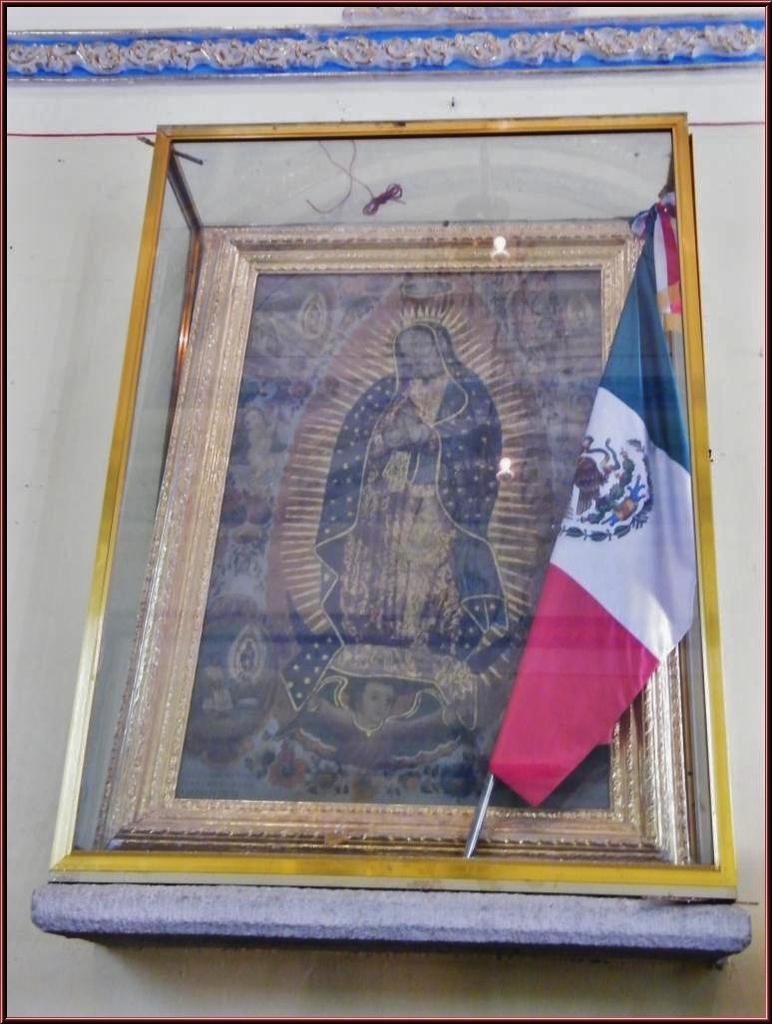Could you give a brief overview of what you see in this image? In this image I can see the white colored wall and I can see a glass box attached to the wall. In the glass box I can see a flag and a photo frame of a person standing. To the top of the image I can see the blue colored design to the wall. 